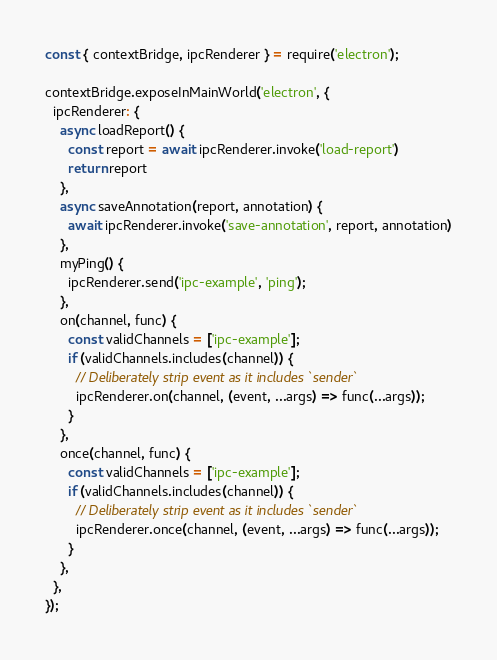Convert code to text. <code><loc_0><loc_0><loc_500><loc_500><_JavaScript_>const { contextBridge, ipcRenderer } = require('electron');

contextBridge.exposeInMainWorld('electron', {
  ipcRenderer: {
    async loadReport() {
      const report = await ipcRenderer.invoke('load-report')
      return report
    },
    async saveAnnotation(report, annotation) {
      await ipcRenderer.invoke('save-annotation', report, annotation)
    },
    myPing() {
      ipcRenderer.send('ipc-example', 'ping');
    },
    on(channel, func) {
      const validChannels = ['ipc-example'];
      if (validChannels.includes(channel)) {
        // Deliberately strip event as it includes `sender`
        ipcRenderer.on(channel, (event, ...args) => func(...args));
      }
    },
    once(channel, func) {
      const validChannels = ['ipc-example'];
      if (validChannels.includes(channel)) {
        // Deliberately strip event as it includes `sender`
        ipcRenderer.once(channel, (event, ...args) => func(...args));
      }
    },
  },
});
</code> 